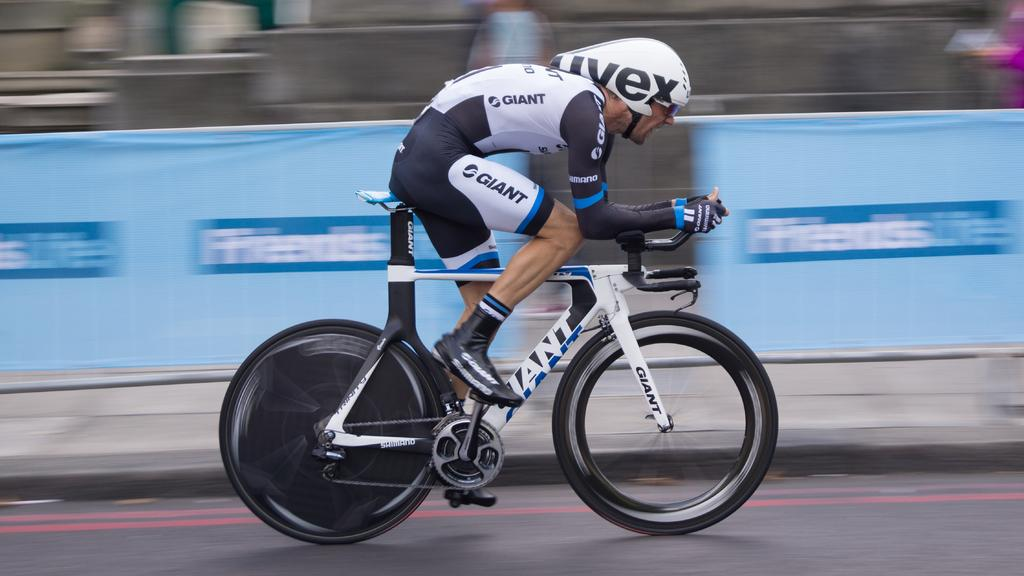<image>
Share a concise interpretation of the image provided. A many riding a bicycle with pants and a bike that say Giant 